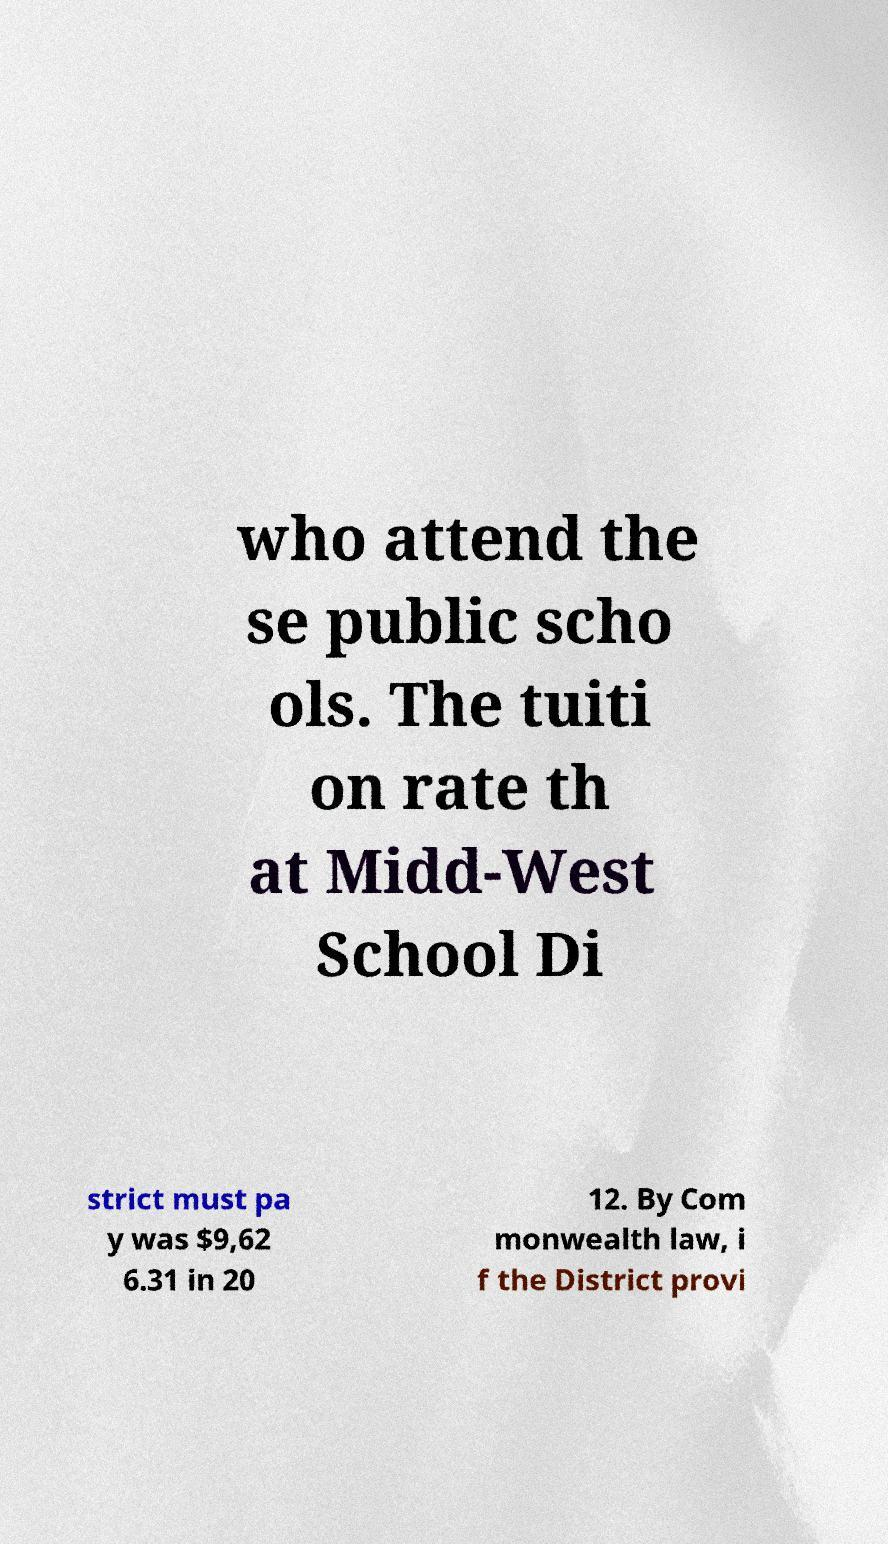I need the written content from this picture converted into text. Can you do that? who attend the se public scho ols. The tuiti on rate th at Midd-West School Di strict must pa y was $9,62 6.31 in 20 12. By Com monwealth law, i f the District provi 